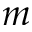Convert formula to latex. <formula><loc_0><loc_0><loc_500><loc_500>m</formula> 